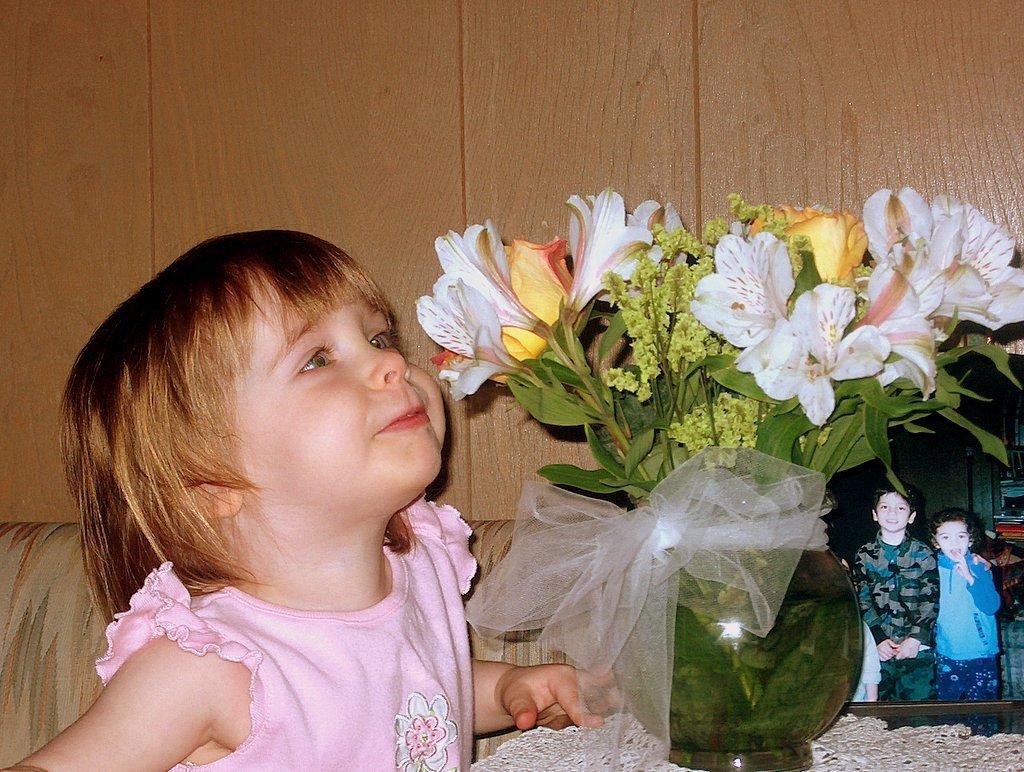Can you describe this image briefly? This picture I can see a baby , in front of the baby I can see flower pot and I can see flowers and leaves and there is a photo visible on the right side, in the photo there is a person's image and there is a wooden wall visible at the top. 